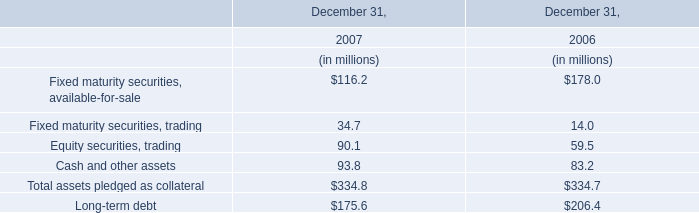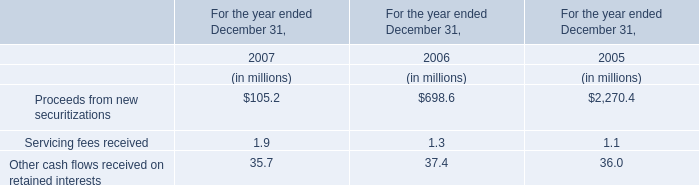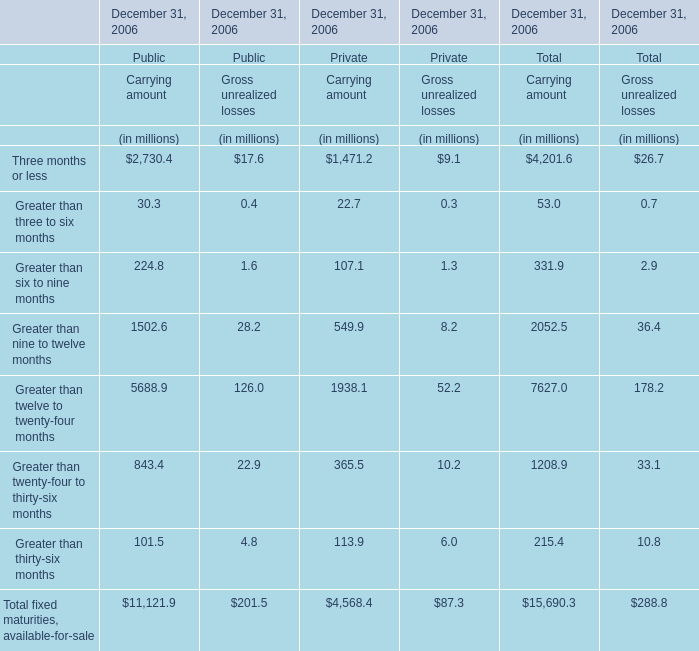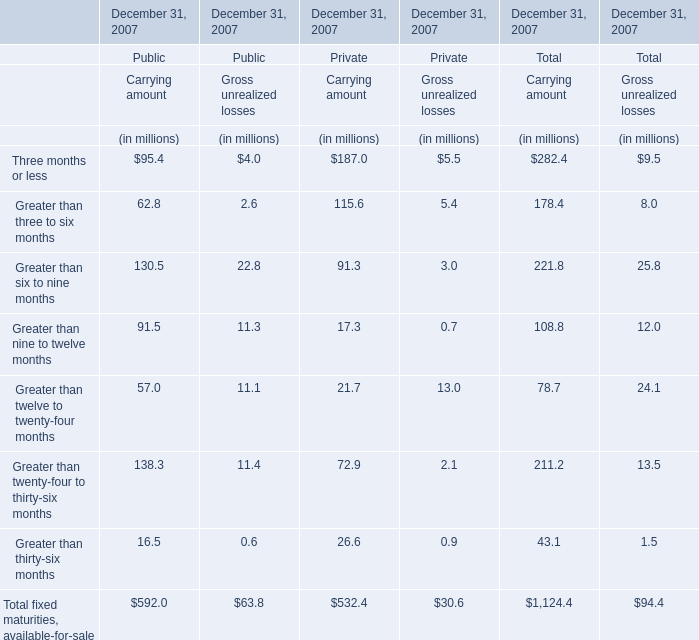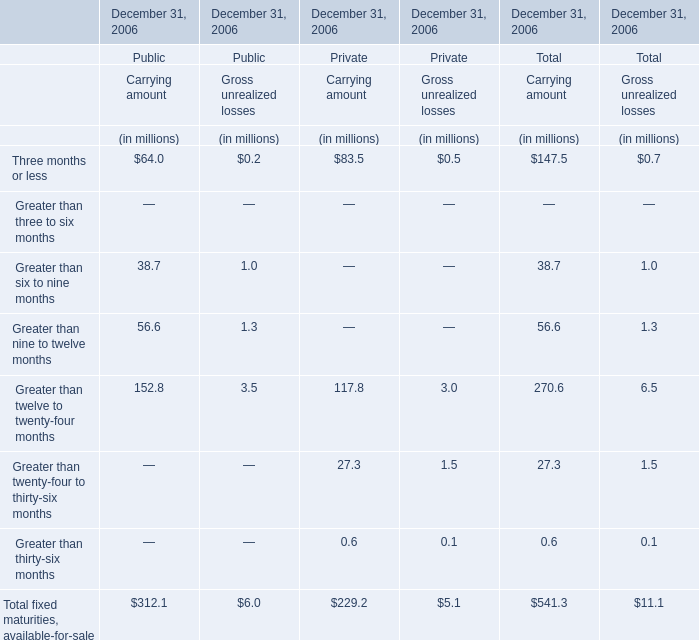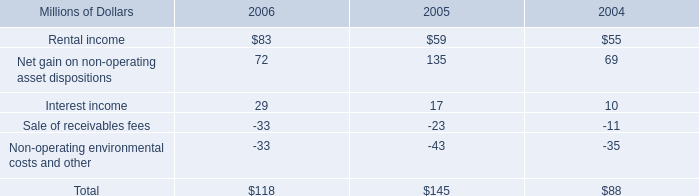What do all Carrying amount of Public sum up, excluding those negative ones in 2007? (in million) 
Answer: 592.0. 